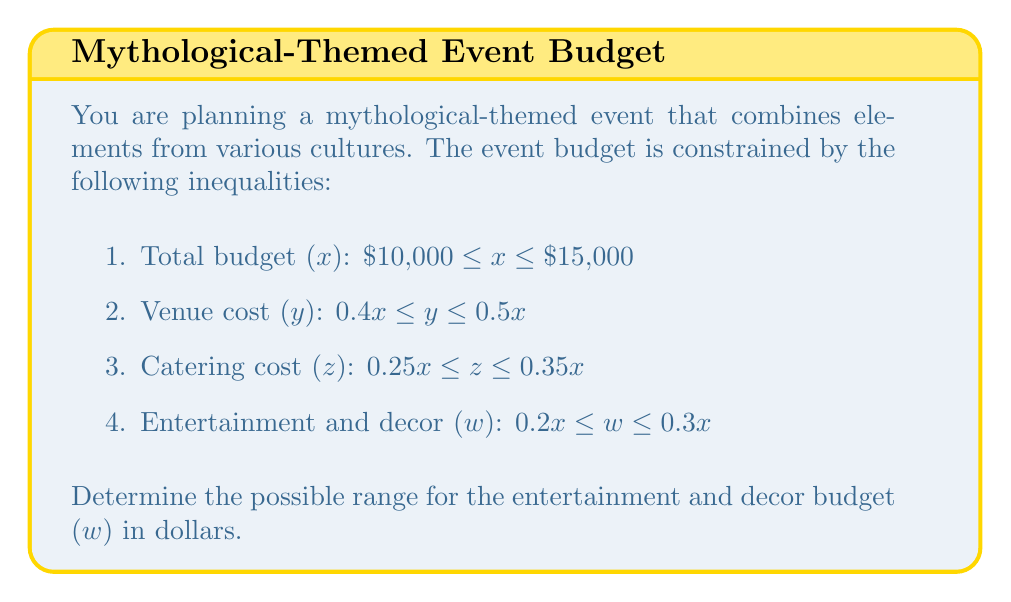Can you solve this math problem? To solve this problem, we'll follow these steps:

1. Identify the bounds for the total budget (x):
   $10,000 \leq x \leq 15,000$

2. Calculate the bounds for the entertainment and decor budget (w):
   $0.2x \leq w \leq 0.3x$

3. Find the minimum possible value for w:
   Minimum w occurs when x is at its minimum ($10,000)
   $w_{min} = 0.2 \times 10,000 = 2,000$

4. Find the maximum possible value for w:
   Maximum w occurs when x is at its maximum ($15,000)
   $w_{max} = 0.3 \times 15,000 = 4,500$

5. Express the range for w:
   $2,000 \leq w \leq 4,500$

Therefore, the possible range for the entertainment and decor budget is between $2,000 and $4,500.
Answer: $2,000 \leq w \leq 4,500$ 